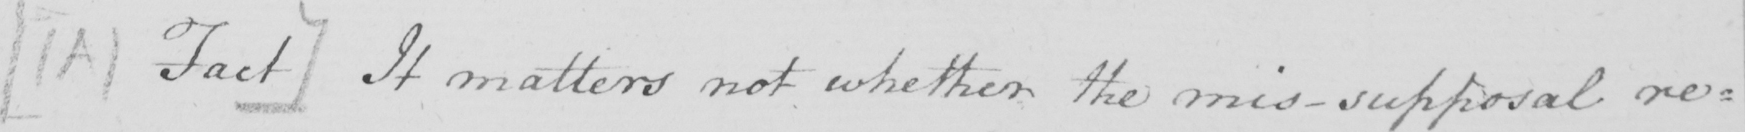Can you tell me what this handwritten text says? [  ( A )  Fact ]  It matters not whether the mis-supposal re= 